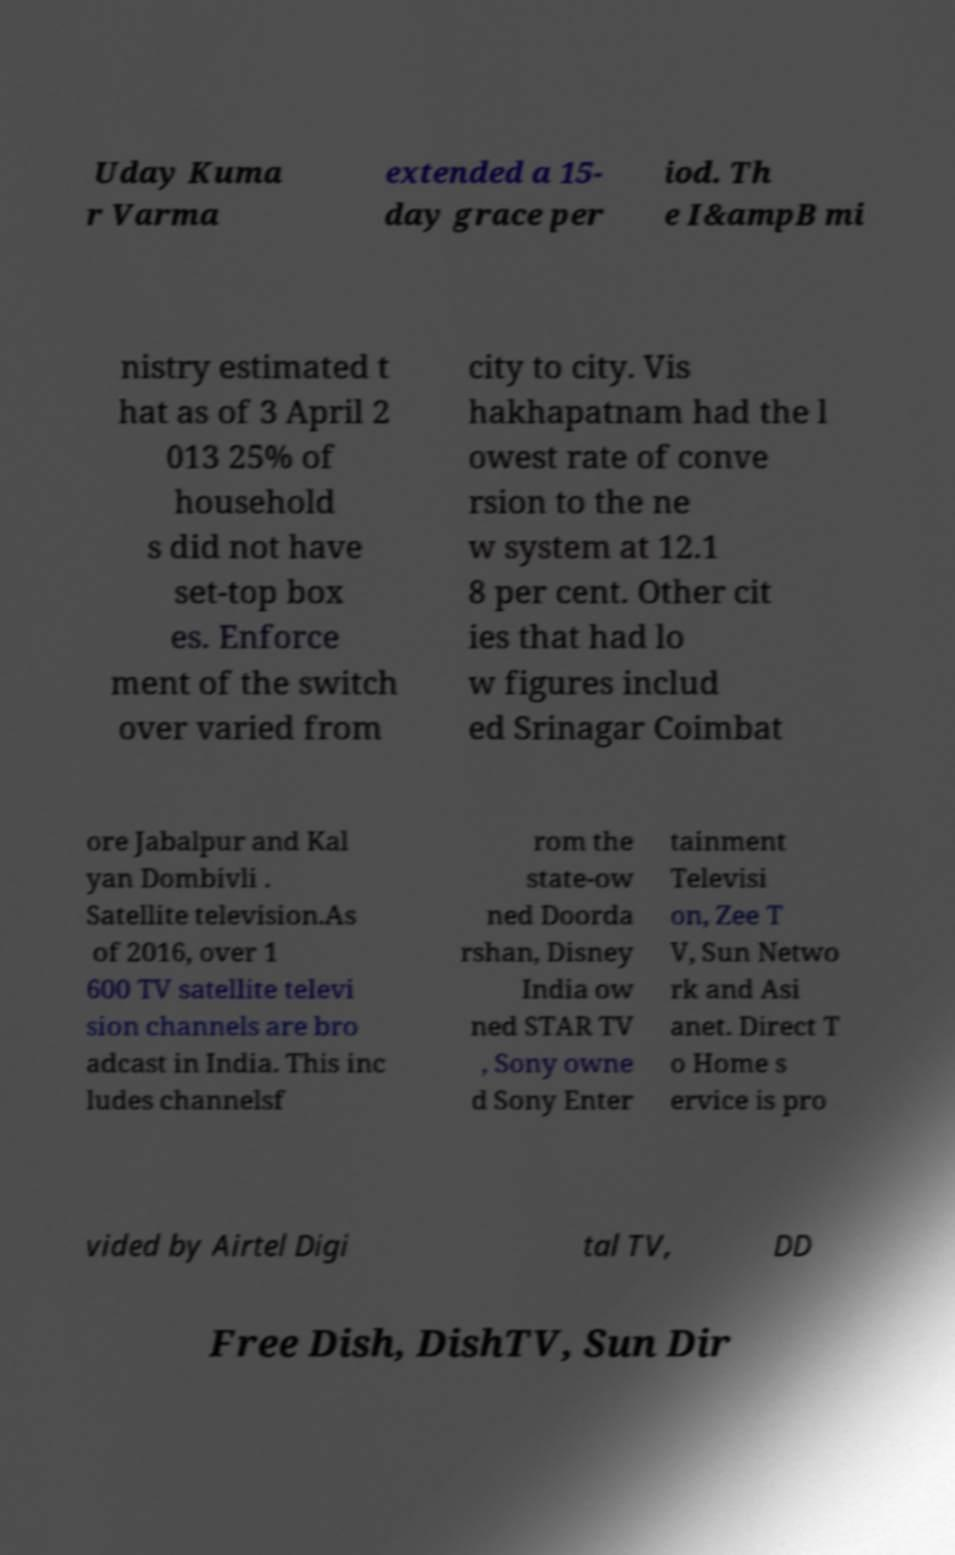Please read and relay the text visible in this image. What does it say? Uday Kuma r Varma extended a 15- day grace per iod. Th e I&ampB mi nistry estimated t hat as of 3 April 2 013 25% of household s did not have set-top box es. Enforce ment of the switch over varied from city to city. Vis hakhapatnam had the l owest rate of conve rsion to the ne w system at 12.1 8 per cent. Other cit ies that had lo w figures includ ed Srinagar Coimbat ore Jabalpur and Kal yan Dombivli . Satellite television.As of 2016, over 1 600 TV satellite televi sion channels are bro adcast in India. This inc ludes channelsf rom the state-ow ned Doorda rshan, Disney India ow ned STAR TV , Sony owne d Sony Enter tainment Televisi on, Zee T V, Sun Netwo rk and Asi anet. Direct T o Home s ervice is pro vided by Airtel Digi tal TV, DD Free Dish, DishTV, Sun Dir 